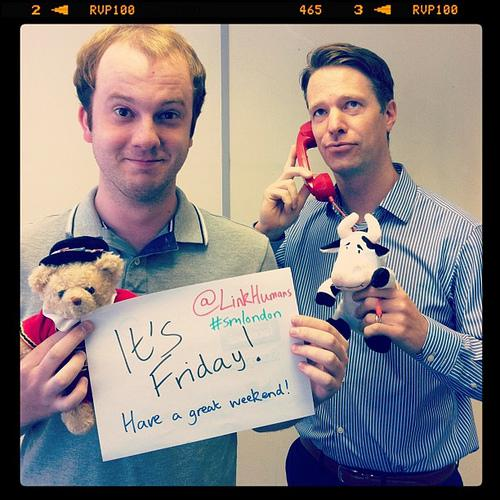Question: how many men are in the photo?
Choices:
A. Two.
B. One.
C. Three.
D. Four.
Answer with the letter. Answer: A Question: what color is the telephone?
Choices:
A. The color red.
B. Blue.
C. Green.
D. Orange.
Answer with the letter. Answer: A Question: when is the picture taken?
Choices:
A. Nighttime.
B. Friday.
C. Winter.
D. Spring.
Answer with the letter. Answer: B Question: what does the sign tell the viewer?
Choices:
A. Have a great weekend.
B. Goodbye.
C. Come back soon.
D. Welcome.
Answer with the letter. Answer: A Question: what type of stuffed animals are the men holding?
Choices:
A. A cow and a bear.
B. Dog and cat.
C. Tiger and cheetah.
D. Turtle and squirrel.
Answer with the letter. Answer: A Question: what is the hashtag on the sign?
Choices:
A. #america.
B. #smlondon.
C. #2015.
D. #disney.
Answer with the letter. Answer: B 